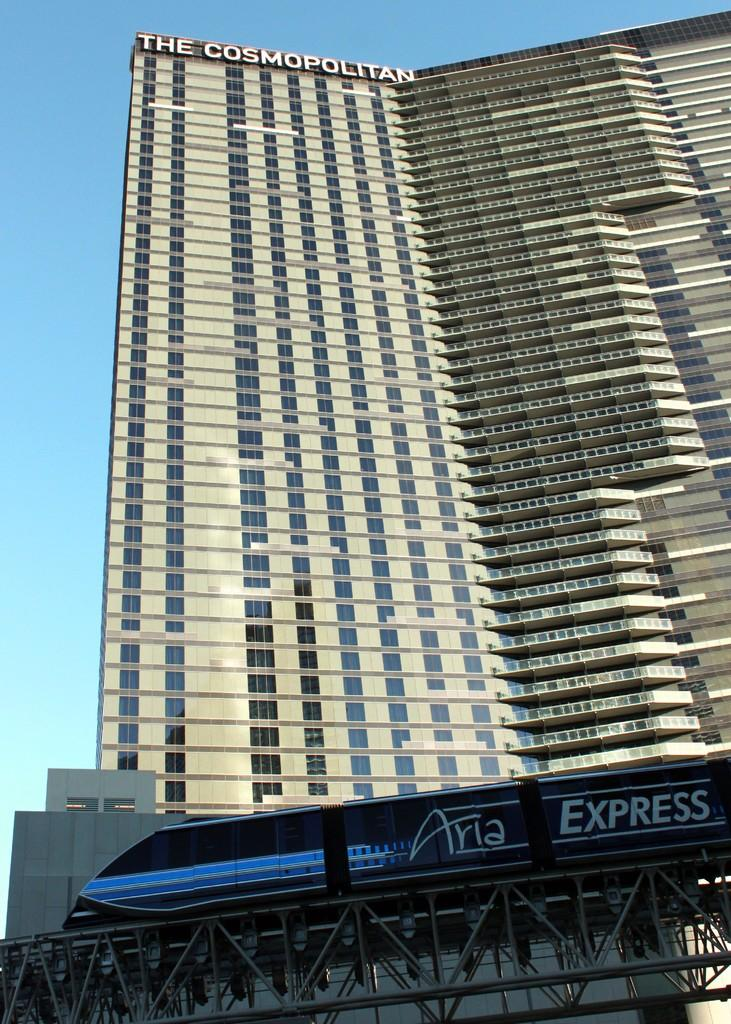<image>
Summarize the visual content of the image. The Cosmopolitan building behind the Aria Express train 